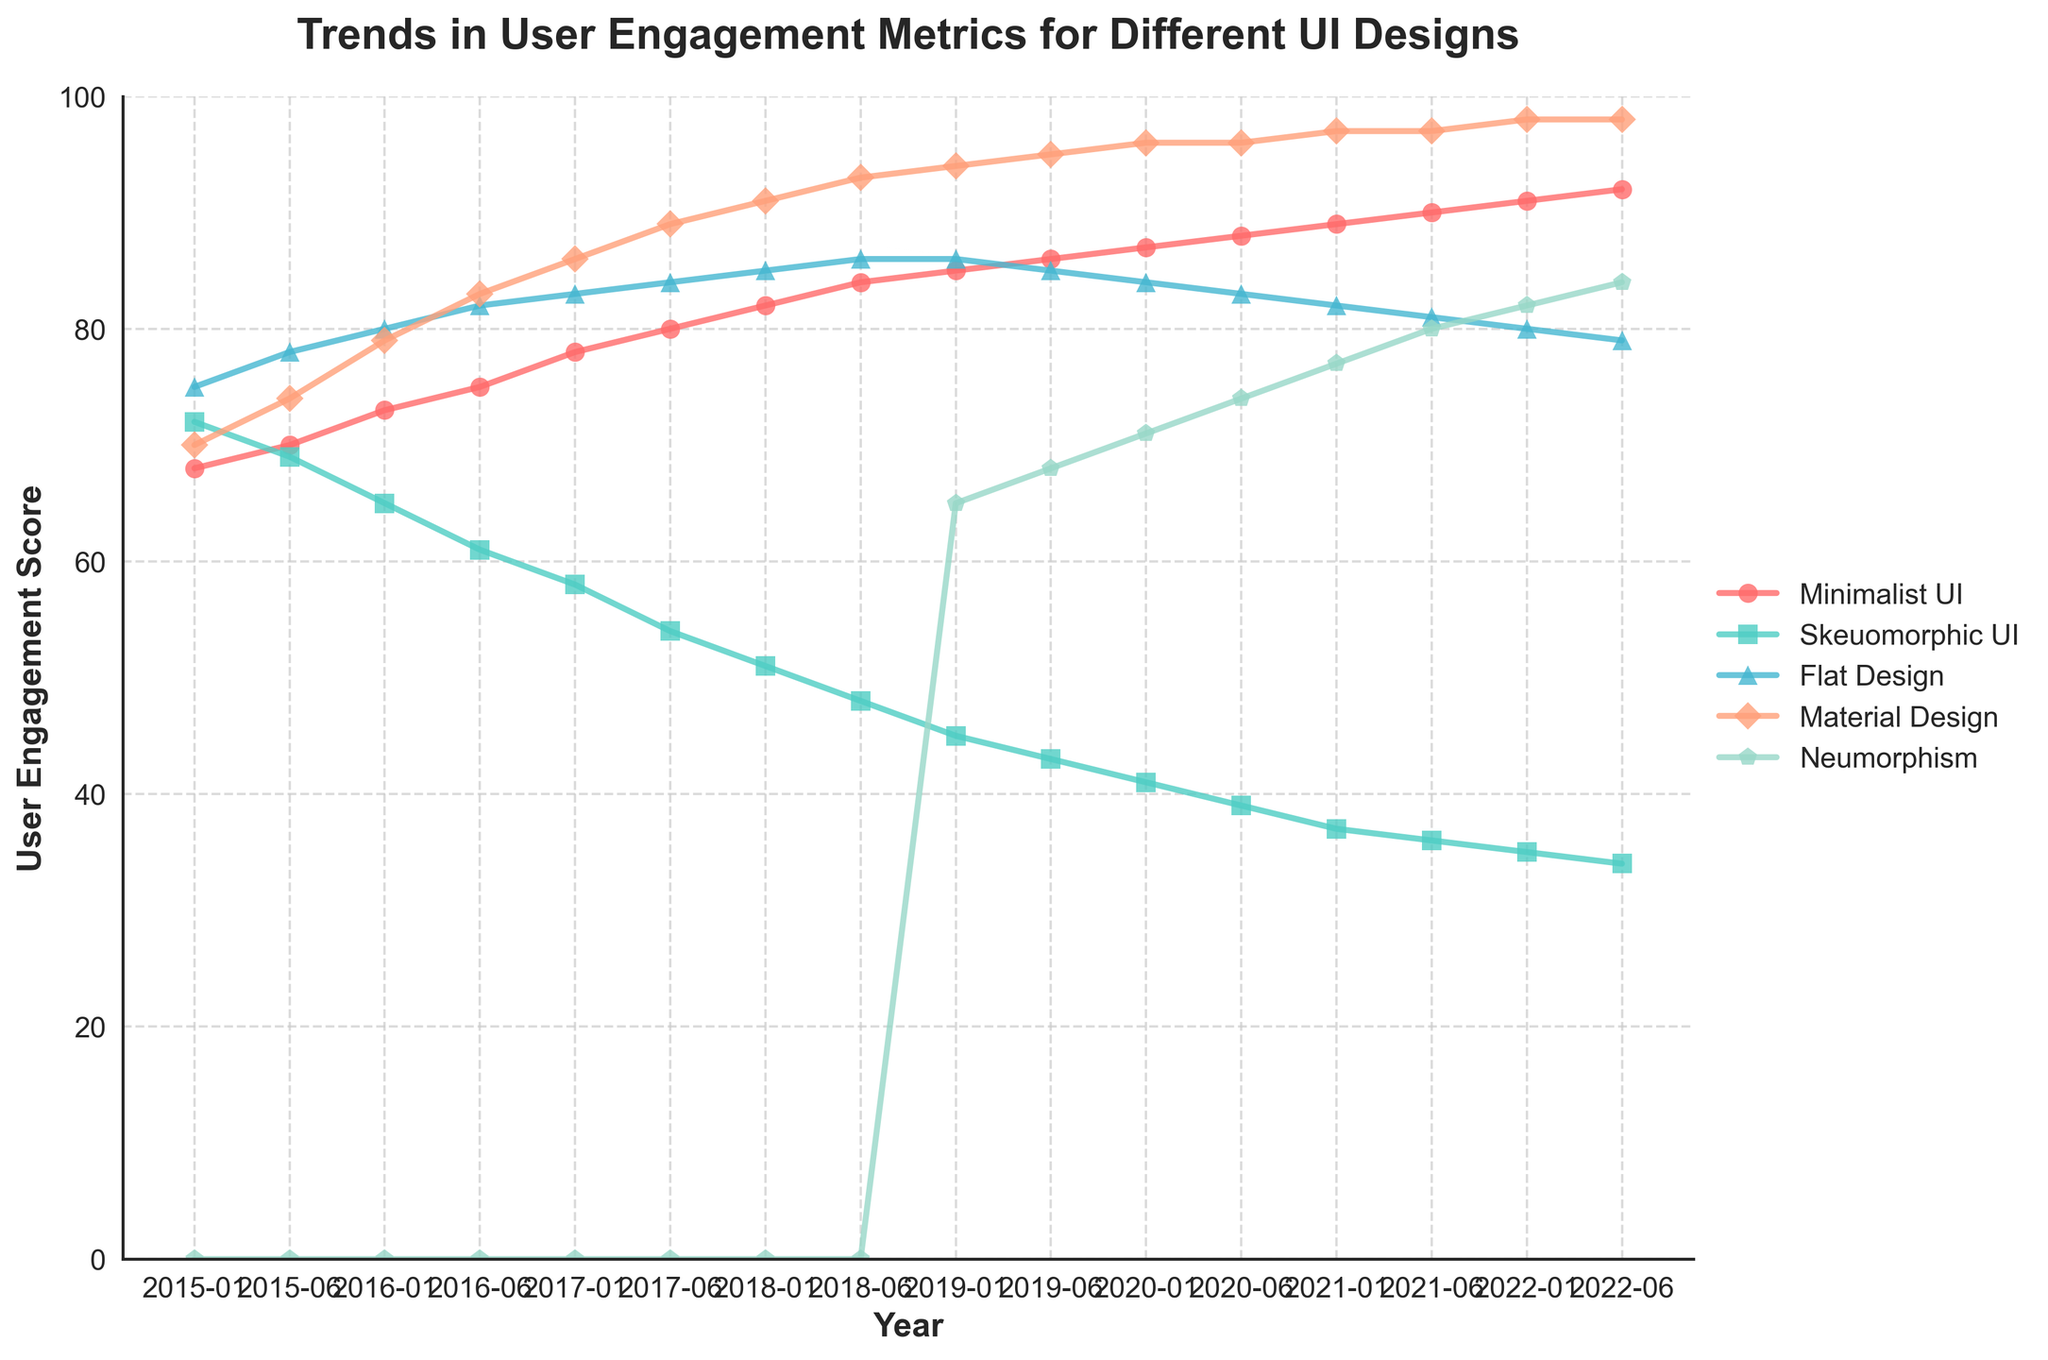Which UI design shows the most consistent increase in user engagement over time? By observing the trend lines in the chart, the "Material Design" shows a steady upward trend without any decline throughout the entire period, indicating consistent improvement.
Answer: Material Design Which UI design had the highest user engagement score in January 2019? Look at the user engagement scores for January 2019. "Material Design" is at 94, which is the highest among all designs for that date.
Answer: Material Design Between "Minimalist UI" and "Neumorphism", which had a higher user engagement score in June 2020? Compare the user engagement scores of "Minimalist UI" (88) and "Neumorphism" (74) in June 2020.
Answer: Minimalist UI Which UI design experienced the greatest decline in user engagement between January 2015 and June 2022? Calculate the difference between the user engagement scores in January 2015 and June 2022 for each design. "Skeuomorphic UI" went from 72 to 34, a drop of 38, which is the largest decline.
Answer: Skeuomorphic UI How did the user engagement trend for "Flat Design" change from 2015 to 2022? Observe the trend line for "Flat Design". Initially, it increased from 75 in January 2015 to 86 in January 2018, then it showed a decline, reaching 79 by June 2022.
Answer: Increased then declined Which UI design had the lowest engagement score in June 2018? Check the user engagement scores for June 2018. "Skeuomorphic UI" is the lowest at 48.
Answer: Skeuomorphic UI By how many points did "Material Design" user engagement score increase from January 2016 to June 2017? The scores are 79 in January 2016 and 89 in June 2017 for "Material Design". Calculate the difference: 89 - 79 = 10.
Answer: 10 Compare the user engagement scores of "Minimalist UI" and "Flat Design" in 2018. Which one had a higher increase by the end of the year? For "Minimalist UI", the score increased from 82 to 84. For "Flat Design", it increased from 85 to 86. "Minimalist UI" had an increase of 2 points, while "Flat Design" had an increase of 1 point.
Answer: Minimalist UI What was the average user engagement score of all UI designs in June 2019? The scores in June 2019 are: 86 (Minimalist UI), 43 (Skeuomorphic UI), 85 (Flat Design), 95 (Material Design), and 68 (Neumorphism). Calculate the average: (86 + 43 + 85 + 95 + 68) / 5 = 75.4.
Answer: 75.4 